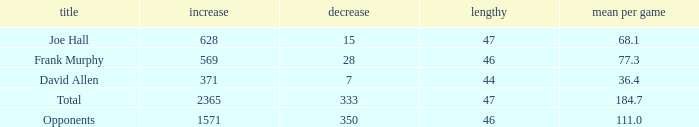Which Avg/G has a Name of david allen, and a Gain larger than 371? None. 